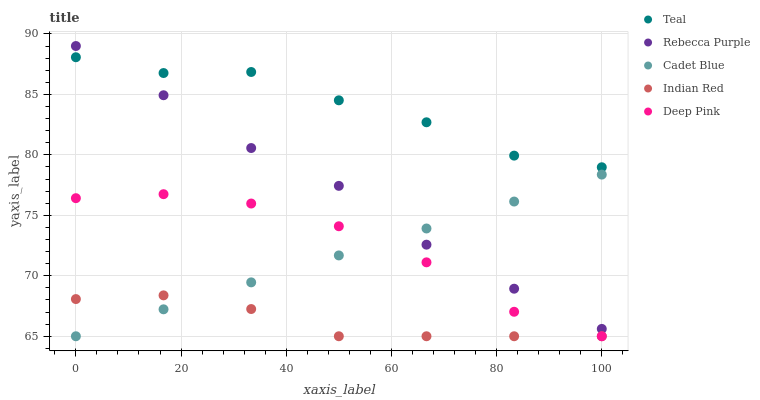Does Indian Red have the minimum area under the curve?
Answer yes or no. Yes. Does Teal have the maximum area under the curve?
Answer yes or no. Yes. Does Cadet Blue have the minimum area under the curve?
Answer yes or no. No. Does Cadet Blue have the maximum area under the curve?
Answer yes or no. No. Is Cadet Blue the smoothest?
Answer yes or no. Yes. Is Teal the roughest?
Answer yes or no. Yes. Is Rebecca Purple the smoothest?
Answer yes or no. No. Is Rebecca Purple the roughest?
Answer yes or no. No. Does Indian Red have the lowest value?
Answer yes or no. Yes. Does Rebecca Purple have the lowest value?
Answer yes or no. No. Does Rebecca Purple have the highest value?
Answer yes or no. Yes. Does Cadet Blue have the highest value?
Answer yes or no. No. Is Cadet Blue less than Teal?
Answer yes or no. Yes. Is Rebecca Purple greater than Deep Pink?
Answer yes or no. Yes. Does Indian Red intersect Deep Pink?
Answer yes or no. Yes. Is Indian Red less than Deep Pink?
Answer yes or no. No. Is Indian Red greater than Deep Pink?
Answer yes or no. No. Does Cadet Blue intersect Teal?
Answer yes or no. No. 